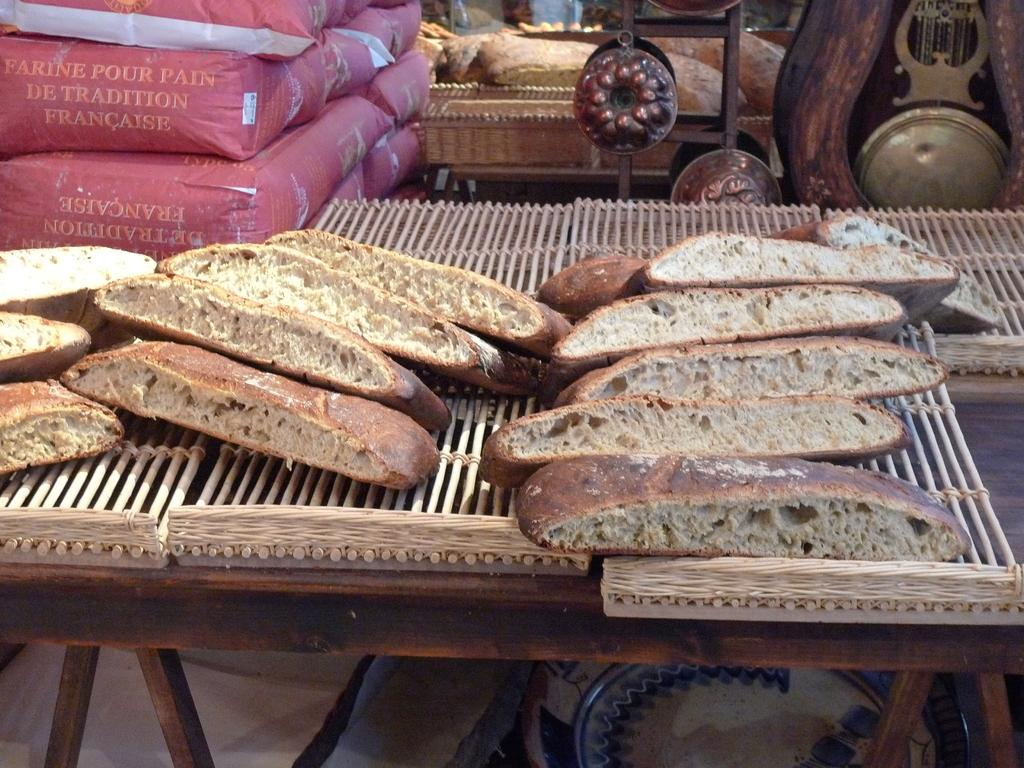What is located at the front of the image? There is a table in the front of the image. What can be found on the table? There are pieces of food on the table. What can be seen in the background of the image? There are bags visible in the background of the image. What type of cloth is being used for scientific experiments in the image? There is no cloth or scientific experiments present in the image. 